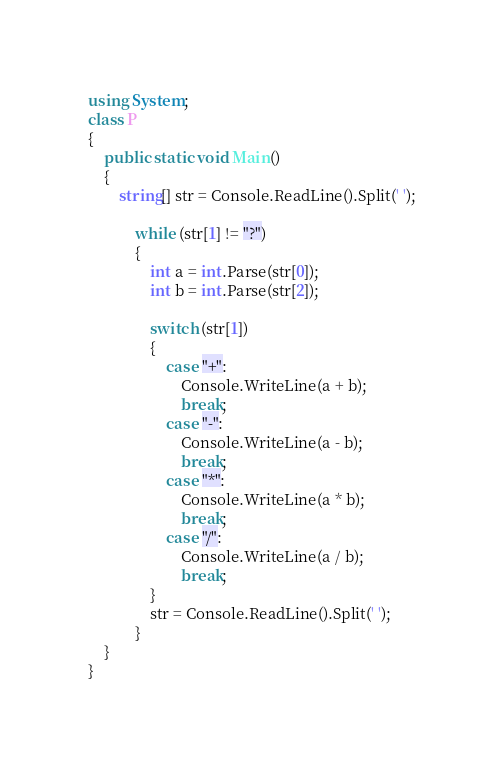Convert code to text. <code><loc_0><loc_0><loc_500><loc_500><_C#_>using System;
class P
{
    public static void Main()
    {
        string[] str = Console.ReadLine().Split(' ');

            while (str[1] != "?")
            {
                int a = int.Parse(str[0]);
                int b = int.Parse(str[2]);

                switch (str[1])
                {
                    case "+":
                        Console.WriteLine(a + b);
                        break;
                    case "-":
                        Console.WriteLine(a - b);
                        break;
                    case "*":
                        Console.WriteLine(a * b);
                        break;
                    case "/":
                        Console.WriteLine(a / b);
                        break;
                }
                str = Console.ReadLine().Split(' ');
            }
    }
}
</code> 